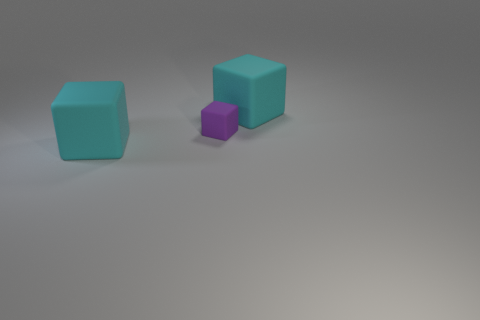There is a cyan rubber thing that is behind the purple cube; what number of big cyan blocks are left of it?
Give a very brief answer. 1. Do the cyan block behind the small cube and the thing that is in front of the tiny purple matte block have the same material?
Make the answer very short. Yes. Are there any other things that have the same shape as the tiny purple object?
Provide a succinct answer. Yes. Are the small cube and the big cyan object that is in front of the tiny rubber block made of the same material?
Ensure brevity in your answer.  Yes. The large thing that is to the right of the large cube in front of the large matte thing behind the tiny purple matte block is what color?
Offer a very short reply. Cyan. Are there any other things that have the same size as the purple rubber thing?
Ensure brevity in your answer.  No. Does the object that is left of the purple rubber block have the same size as the cyan rubber object on the right side of the tiny purple rubber cube?
Ensure brevity in your answer.  Yes. What size is the rubber thing that is behind the purple cube?
Provide a short and direct response. Large. What number of rubber objects are cyan objects or big gray objects?
Provide a succinct answer. 2. Are there more purple blocks in front of the purple rubber thing than small objects?
Your response must be concise. No. 